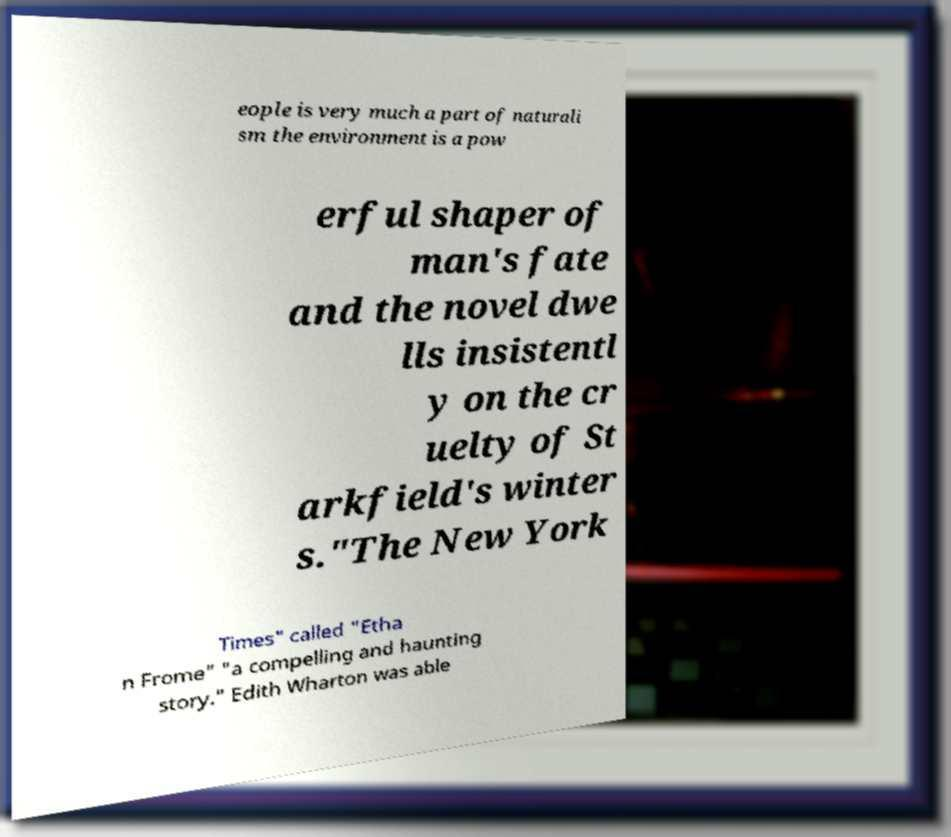Can you read and provide the text displayed in the image?This photo seems to have some interesting text. Can you extract and type it out for me? eople is very much a part of naturali sm the environment is a pow erful shaper of man's fate and the novel dwe lls insistentl y on the cr uelty of St arkfield's winter s."The New York Times" called "Etha n Frome" "a compelling and haunting story." Edith Wharton was able 